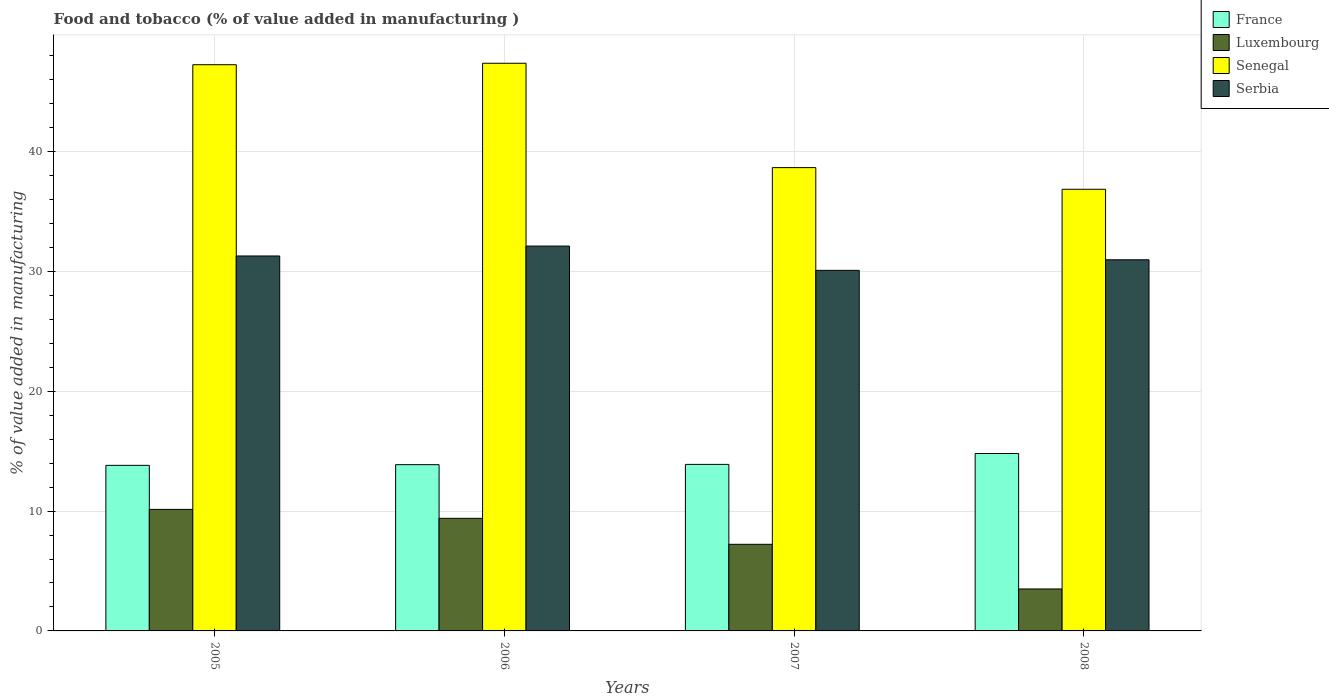How many groups of bars are there?
Make the answer very short. 4. Are the number of bars on each tick of the X-axis equal?
Your answer should be very brief. Yes. How many bars are there on the 1st tick from the left?
Your answer should be very brief. 4. How many bars are there on the 1st tick from the right?
Keep it short and to the point. 4. What is the label of the 4th group of bars from the left?
Your response must be concise. 2008. What is the value added in manufacturing food and tobacco in Serbia in 2006?
Give a very brief answer. 32.12. Across all years, what is the maximum value added in manufacturing food and tobacco in Serbia?
Give a very brief answer. 32.12. Across all years, what is the minimum value added in manufacturing food and tobacco in Senegal?
Your answer should be compact. 36.86. In which year was the value added in manufacturing food and tobacco in Luxembourg maximum?
Offer a terse response. 2005. In which year was the value added in manufacturing food and tobacco in Luxembourg minimum?
Ensure brevity in your answer.  2008. What is the total value added in manufacturing food and tobacco in Luxembourg in the graph?
Your answer should be very brief. 30.27. What is the difference between the value added in manufacturing food and tobacco in Luxembourg in 2006 and that in 2008?
Make the answer very short. 5.9. What is the difference between the value added in manufacturing food and tobacco in France in 2005 and the value added in manufacturing food and tobacco in Serbia in 2006?
Your response must be concise. -18.3. What is the average value added in manufacturing food and tobacco in France per year?
Provide a short and direct response. 14.1. In the year 2008, what is the difference between the value added in manufacturing food and tobacco in Serbia and value added in manufacturing food and tobacco in France?
Give a very brief answer. 16.17. What is the ratio of the value added in manufacturing food and tobacco in France in 2007 to that in 2008?
Ensure brevity in your answer.  0.94. Is the value added in manufacturing food and tobacco in Luxembourg in 2007 less than that in 2008?
Ensure brevity in your answer.  No. What is the difference between the highest and the second highest value added in manufacturing food and tobacco in Luxembourg?
Your response must be concise. 0.75. What is the difference between the highest and the lowest value added in manufacturing food and tobacco in Serbia?
Provide a succinct answer. 2.03. What does the 3rd bar from the left in 2006 represents?
Ensure brevity in your answer.  Senegal. What does the 1st bar from the right in 2008 represents?
Give a very brief answer. Serbia. Is it the case that in every year, the sum of the value added in manufacturing food and tobacco in Serbia and value added in manufacturing food and tobacco in France is greater than the value added in manufacturing food and tobacco in Luxembourg?
Your answer should be compact. Yes. How many bars are there?
Keep it short and to the point. 16. How many years are there in the graph?
Keep it short and to the point. 4. What is the difference between two consecutive major ticks on the Y-axis?
Your answer should be very brief. 10. Are the values on the major ticks of Y-axis written in scientific E-notation?
Your answer should be compact. No. Does the graph contain any zero values?
Give a very brief answer. No. Does the graph contain grids?
Keep it short and to the point. Yes. How many legend labels are there?
Your answer should be very brief. 4. How are the legend labels stacked?
Provide a succinct answer. Vertical. What is the title of the graph?
Keep it short and to the point. Food and tobacco (% of value added in manufacturing ). What is the label or title of the X-axis?
Provide a short and direct response. Years. What is the label or title of the Y-axis?
Give a very brief answer. % of value added in manufacturing. What is the % of value added in manufacturing in France in 2005?
Offer a very short reply. 13.82. What is the % of value added in manufacturing in Luxembourg in 2005?
Offer a terse response. 10.14. What is the % of value added in manufacturing in Senegal in 2005?
Make the answer very short. 47.25. What is the % of value added in manufacturing of Serbia in 2005?
Ensure brevity in your answer.  31.29. What is the % of value added in manufacturing of France in 2006?
Keep it short and to the point. 13.88. What is the % of value added in manufacturing of Luxembourg in 2006?
Provide a short and direct response. 9.4. What is the % of value added in manufacturing in Senegal in 2006?
Your answer should be very brief. 47.38. What is the % of value added in manufacturing of Serbia in 2006?
Give a very brief answer. 32.12. What is the % of value added in manufacturing in France in 2007?
Keep it short and to the point. 13.9. What is the % of value added in manufacturing in Luxembourg in 2007?
Your answer should be compact. 7.23. What is the % of value added in manufacturing in Senegal in 2007?
Offer a terse response. 38.67. What is the % of value added in manufacturing in Serbia in 2007?
Ensure brevity in your answer.  30.09. What is the % of value added in manufacturing of France in 2008?
Keep it short and to the point. 14.81. What is the % of value added in manufacturing of Luxembourg in 2008?
Keep it short and to the point. 3.5. What is the % of value added in manufacturing of Senegal in 2008?
Offer a terse response. 36.86. What is the % of value added in manufacturing in Serbia in 2008?
Your response must be concise. 30.97. Across all years, what is the maximum % of value added in manufacturing in France?
Your response must be concise. 14.81. Across all years, what is the maximum % of value added in manufacturing in Luxembourg?
Offer a terse response. 10.14. Across all years, what is the maximum % of value added in manufacturing of Senegal?
Provide a succinct answer. 47.38. Across all years, what is the maximum % of value added in manufacturing in Serbia?
Keep it short and to the point. 32.12. Across all years, what is the minimum % of value added in manufacturing of France?
Make the answer very short. 13.82. Across all years, what is the minimum % of value added in manufacturing in Luxembourg?
Give a very brief answer. 3.5. Across all years, what is the minimum % of value added in manufacturing of Senegal?
Your answer should be compact. 36.86. Across all years, what is the minimum % of value added in manufacturing of Serbia?
Keep it short and to the point. 30.09. What is the total % of value added in manufacturing in France in the graph?
Your response must be concise. 56.4. What is the total % of value added in manufacturing of Luxembourg in the graph?
Provide a succinct answer. 30.27. What is the total % of value added in manufacturing in Senegal in the graph?
Offer a very short reply. 170.16. What is the total % of value added in manufacturing of Serbia in the graph?
Your answer should be very brief. 124.48. What is the difference between the % of value added in manufacturing in France in 2005 and that in 2006?
Provide a succinct answer. -0.06. What is the difference between the % of value added in manufacturing of Luxembourg in 2005 and that in 2006?
Provide a short and direct response. 0.75. What is the difference between the % of value added in manufacturing of Senegal in 2005 and that in 2006?
Ensure brevity in your answer.  -0.12. What is the difference between the % of value added in manufacturing of Serbia in 2005 and that in 2006?
Your answer should be very brief. -0.83. What is the difference between the % of value added in manufacturing in France in 2005 and that in 2007?
Keep it short and to the point. -0.08. What is the difference between the % of value added in manufacturing in Luxembourg in 2005 and that in 2007?
Provide a succinct answer. 2.91. What is the difference between the % of value added in manufacturing of Senegal in 2005 and that in 2007?
Provide a succinct answer. 8.59. What is the difference between the % of value added in manufacturing in Serbia in 2005 and that in 2007?
Keep it short and to the point. 1.2. What is the difference between the % of value added in manufacturing of France in 2005 and that in 2008?
Your answer should be very brief. -0.99. What is the difference between the % of value added in manufacturing of Luxembourg in 2005 and that in 2008?
Provide a succinct answer. 6.64. What is the difference between the % of value added in manufacturing in Senegal in 2005 and that in 2008?
Provide a succinct answer. 10.4. What is the difference between the % of value added in manufacturing of Serbia in 2005 and that in 2008?
Offer a very short reply. 0.32. What is the difference between the % of value added in manufacturing in France in 2006 and that in 2007?
Your answer should be very brief. -0.02. What is the difference between the % of value added in manufacturing of Luxembourg in 2006 and that in 2007?
Offer a terse response. 2.17. What is the difference between the % of value added in manufacturing in Senegal in 2006 and that in 2007?
Keep it short and to the point. 8.71. What is the difference between the % of value added in manufacturing in Serbia in 2006 and that in 2007?
Provide a succinct answer. 2.03. What is the difference between the % of value added in manufacturing of France in 2006 and that in 2008?
Offer a terse response. -0.93. What is the difference between the % of value added in manufacturing of Luxembourg in 2006 and that in 2008?
Your response must be concise. 5.9. What is the difference between the % of value added in manufacturing of Senegal in 2006 and that in 2008?
Offer a very short reply. 10.52. What is the difference between the % of value added in manufacturing of Serbia in 2006 and that in 2008?
Your answer should be compact. 1.15. What is the difference between the % of value added in manufacturing of France in 2007 and that in 2008?
Keep it short and to the point. -0.91. What is the difference between the % of value added in manufacturing of Luxembourg in 2007 and that in 2008?
Make the answer very short. 3.73. What is the difference between the % of value added in manufacturing in Senegal in 2007 and that in 2008?
Your answer should be very brief. 1.81. What is the difference between the % of value added in manufacturing in Serbia in 2007 and that in 2008?
Make the answer very short. -0.88. What is the difference between the % of value added in manufacturing in France in 2005 and the % of value added in manufacturing in Luxembourg in 2006?
Offer a very short reply. 4.42. What is the difference between the % of value added in manufacturing in France in 2005 and the % of value added in manufacturing in Senegal in 2006?
Ensure brevity in your answer.  -33.56. What is the difference between the % of value added in manufacturing of France in 2005 and the % of value added in manufacturing of Serbia in 2006?
Your answer should be compact. -18.3. What is the difference between the % of value added in manufacturing of Luxembourg in 2005 and the % of value added in manufacturing of Senegal in 2006?
Ensure brevity in your answer.  -37.23. What is the difference between the % of value added in manufacturing in Luxembourg in 2005 and the % of value added in manufacturing in Serbia in 2006?
Make the answer very short. -21.98. What is the difference between the % of value added in manufacturing in Senegal in 2005 and the % of value added in manufacturing in Serbia in 2006?
Ensure brevity in your answer.  15.13. What is the difference between the % of value added in manufacturing in France in 2005 and the % of value added in manufacturing in Luxembourg in 2007?
Your response must be concise. 6.59. What is the difference between the % of value added in manufacturing in France in 2005 and the % of value added in manufacturing in Senegal in 2007?
Offer a very short reply. -24.85. What is the difference between the % of value added in manufacturing of France in 2005 and the % of value added in manufacturing of Serbia in 2007?
Your response must be concise. -16.27. What is the difference between the % of value added in manufacturing of Luxembourg in 2005 and the % of value added in manufacturing of Senegal in 2007?
Ensure brevity in your answer.  -28.52. What is the difference between the % of value added in manufacturing of Luxembourg in 2005 and the % of value added in manufacturing of Serbia in 2007?
Ensure brevity in your answer.  -19.95. What is the difference between the % of value added in manufacturing in Senegal in 2005 and the % of value added in manufacturing in Serbia in 2007?
Offer a very short reply. 17.16. What is the difference between the % of value added in manufacturing in France in 2005 and the % of value added in manufacturing in Luxembourg in 2008?
Your answer should be compact. 10.32. What is the difference between the % of value added in manufacturing of France in 2005 and the % of value added in manufacturing of Senegal in 2008?
Offer a terse response. -23.04. What is the difference between the % of value added in manufacturing of France in 2005 and the % of value added in manufacturing of Serbia in 2008?
Your answer should be compact. -17.16. What is the difference between the % of value added in manufacturing in Luxembourg in 2005 and the % of value added in manufacturing in Senegal in 2008?
Keep it short and to the point. -26.72. What is the difference between the % of value added in manufacturing of Luxembourg in 2005 and the % of value added in manufacturing of Serbia in 2008?
Your response must be concise. -20.83. What is the difference between the % of value added in manufacturing of Senegal in 2005 and the % of value added in manufacturing of Serbia in 2008?
Provide a succinct answer. 16.28. What is the difference between the % of value added in manufacturing of France in 2006 and the % of value added in manufacturing of Luxembourg in 2007?
Give a very brief answer. 6.65. What is the difference between the % of value added in manufacturing of France in 2006 and the % of value added in manufacturing of Senegal in 2007?
Ensure brevity in your answer.  -24.79. What is the difference between the % of value added in manufacturing of France in 2006 and the % of value added in manufacturing of Serbia in 2007?
Ensure brevity in your answer.  -16.22. What is the difference between the % of value added in manufacturing of Luxembourg in 2006 and the % of value added in manufacturing of Senegal in 2007?
Give a very brief answer. -29.27. What is the difference between the % of value added in manufacturing of Luxembourg in 2006 and the % of value added in manufacturing of Serbia in 2007?
Make the answer very short. -20.69. What is the difference between the % of value added in manufacturing of Senegal in 2006 and the % of value added in manufacturing of Serbia in 2007?
Give a very brief answer. 17.28. What is the difference between the % of value added in manufacturing of France in 2006 and the % of value added in manufacturing of Luxembourg in 2008?
Offer a terse response. 10.37. What is the difference between the % of value added in manufacturing in France in 2006 and the % of value added in manufacturing in Senegal in 2008?
Offer a terse response. -22.98. What is the difference between the % of value added in manufacturing of France in 2006 and the % of value added in manufacturing of Serbia in 2008?
Provide a succinct answer. -17.1. What is the difference between the % of value added in manufacturing in Luxembourg in 2006 and the % of value added in manufacturing in Senegal in 2008?
Offer a terse response. -27.46. What is the difference between the % of value added in manufacturing in Luxembourg in 2006 and the % of value added in manufacturing in Serbia in 2008?
Your answer should be very brief. -21.58. What is the difference between the % of value added in manufacturing in Senegal in 2006 and the % of value added in manufacturing in Serbia in 2008?
Your answer should be very brief. 16.4. What is the difference between the % of value added in manufacturing in France in 2007 and the % of value added in manufacturing in Luxembourg in 2008?
Make the answer very short. 10.4. What is the difference between the % of value added in manufacturing of France in 2007 and the % of value added in manufacturing of Senegal in 2008?
Provide a succinct answer. -22.96. What is the difference between the % of value added in manufacturing of France in 2007 and the % of value added in manufacturing of Serbia in 2008?
Offer a terse response. -17.08. What is the difference between the % of value added in manufacturing in Luxembourg in 2007 and the % of value added in manufacturing in Senegal in 2008?
Your response must be concise. -29.63. What is the difference between the % of value added in manufacturing in Luxembourg in 2007 and the % of value added in manufacturing in Serbia in 2008?
Provide a succinct answer. -23.75. What is the difference between the % of value added in manufacturing in Senegal in 2007 and the % of value added in manufacturing in Serbia in 2008?
Offer a terse response. 7.69. What is the average % of value added in manufacturing of France per year?
Provide a short and direct response. 14.1. What is the average % of value added in manufacturing in Luxembourg per year?
Keep it short and to the point. 7.57. What is the average % of value added in manufacturing in Senegal per year?
Ensure brevity in your answer.  42.54. What is the average % of value added in manufacturing in Serbia per year?
Give a very brief answer. 31.12. In the year 2005, what is the difference between the % of value added in manufacturing in France and % of value added in manufacturing in Luxembourg?
Offer a very short reply. 3.68. In the year 2005, what is the difference between the % of value added in manufacturing in France and % of value added in manufacturing in Senegal?
Make the answer very short. -33.44. In the year 2005, what is the difference between the % of value added in manufacturing in France and % of value added in manufacturing in Serbia?
Your answer should be compact. -17.47. In the year 2005, what is the difference between the % of value added in manufacturing in Luxembourg and % of value added in manufacturing in Senegal?
Your answer should be very brief. -37.11. In the year 2005, what is the difference between the % of value added in manufacturing of Luxembourg and % of value added in manufacturing of Serbia?
Ensure brevity in your answer.  -21.15. In the year 2005, what is the difference between the % of value added in manufacturing of Senegal and % of value added in manufacturing of Serbia?
Your response must be concise. 15.96. In the year 2006, what is the difference between the % of value added in manufacturing of France and % of value added in manufacturing of Luxembourg?
Offer a terse response. 4.48. In the year 2006, what is the difference between the % of value added in manufacturing of France and % of value added in manufacturing of Senegal?
Give a very brief answer. -33.5. In the year 2006, what is the difference between the % of value added in manufacturing of France and % of value added in manufacturing of Serbia?
Make the answer very short. -18.25. In the year 2006, what is the difference between the % of value added in manufacturing in Luxembourg and % of value added in manufacturing in Senegal?
Give a very brief answer. -37.98. In the year 2006, what is the difference between the % of value added in manufacturing in Luxembourg and % of value added in manufacturing in Serbia?
Your response must be concise. -22.72. In the year 2006, what is the difference between the % of value added in manufacturing of Senegal and % of value added in manufacturing of Serbia?
Ensure brevity in your answer.  15.26. In the year 2007, what is the difference between the % of value added in manufacturing of France and % of value added in manufacturing of Luxembourg?
Your response must be concise. 6.67. In the year 2007, what is the difference between the % of value added in manufacturing of France and % of value added in manufacturing of Senegal?
Offer a terse response. -24.77. In the year 2007, what is the difference between the % of value added in manufacturing of France and % of value added in manufacturing of Serbia?
Your answer should be very brief. -16.2. In the year 2007, what is the difference between the % of value added in manufacturing in Luxembourg and % of value added in manufacturing in Senegal?
Ensure brevity in your answer.  -31.44. In the year 2007, what is the difference between the % of value added in manufacturing of Luxembourg and % of value added in manufacturing of Serbia?
Offer a terse response. -22.86. In the year 2007, what is the difference between the % of value added in manufacturing of Senegal and % of value added in manufacturing of Serbia?
Your response must be concise. 8.57. In the year 2008, what is the difference between the % of value added in manufacturing of France and % of value added in manufacturing of Luxembourg?
Provide a succinct answer. 11.31. In the year 2008, what is the difference between the % of value added in manufacturing in France and % of value added in manufacturing in Senegal?
Your response must be concise. -22.05. In the year 2008, what is the difference between the % of value added in manufacturing of France and % of value added in manufacturing of Serbia?
Offer a terse response. -16.17. In the year 2008, what is the difference between the % of value added in manufacturing of Luxembourg and % of value added in manufacturing of Senegal?
Provide a succinct answer. -33.36. In the year 2008, what is the difference between the % of value added in manufacturing in Luxembourg and % of value added in manufacturing in Serbia?
Keep it short and to the point. -27.47. In the year 2008, what is the difference between the % of value added in manufacturing in Senegal and % of value added in manufacturing in Serbia?
Offer a terse response. 5.88. What is the ratio of the % of value added in manufacturing in Luxembourg in 2005 to that in 2006?
Keep it short and to the point. 1.08. What is the ratio of the % of value added in manufacturing of Serbia in 2005 to that in 2006?
Give a very brief answer. 0.97. What is the ratio of the % of value added in manufacturing of France in 2005 to that in 2007?
Provide a succinct answer. 0.99. What is the ratio of the % of value added in manufacturing of Luxembourg in 2005 to that in 2007?
Your answer should be very brief. 1.4. What is the ratio of the % of value added in manufacturing of Senegal in 2005 to that in 2007?
Ensure brevity in your answer.  1.22. What is the ratio of the % of value added in manufacturing in Serbia in 2005 to that in 2007?
Your answer should be very brief. 1.04. What is the ratio of the % of value added in manufacturing of France in 2005 to that in 2008?
Offer a terse response. 0.93. What is the ratio of the % of value added in manufacturing in Luxembourg in 2005 to that in 2008?
Give a very brief answer. 2.9. What is the ratio of the % of value added in manufacturing in Senegal in 2005 to that in 2008?
Offer a terse response. 1.28. What is the ratio of the % of value added in manufacturing of Serbia in 2005 to that in 2008?
Your answer should be very brief. 1.01. What is the ratio of the % of value added in manufacturing in Senegal in 2006 to that in 2007?
Keep it short and to the point. 1.23. What is the ratio of the % of value added in manufacturing of Serbia in 2006 to that in 2007?
Ensure brevity in your answer.  1.07. What is the ratio of the % of value added in manufacturing of France in 2006 to that in 2008?
Give a very brief answer. 0.94. What is the ratio of the % of value added in manufacturing of Luxembourg in 2006 to that in 2008?
Make the answer very short. 2.68. What is the ratio of the % of value added in manufacturing of Senegal in 2006 to that in 2008?
Your response must be concise. 1.29. What is the ratio of the % of value added in manufacturing of Serbia in 2006 to that in 2008?
Ensure brevity in your answer.  1.04. What is the ratio of the % of value added in manufacturing of France in 2007 to that in 2008?
Offer a very short reply. 0.94. What is the ratio of the % of value added in manufacturing of Luxembourg in 2007 to that in 2008?
Your answer should be very brief. 2.06. What is the ratio of the % of value added in manufacturing of Senegal in 2007 to that in 2008?
Offer a very short reply. 1.05. What is the ratio of the % of value added in manufacturing in Serbia in 2007 to that in 2008?
Your answer should be compact. 0.97. What is the difference between the highest and the second highest % of value added in manufacturing of France?
Give a very brief answer. 0.91. What is the difference between the highest and the second highest % of value added in manufacturing of Luxembourg?
Your answer should be compact. 0.75. What is the difference between the highest and the second highest % of value added in manufacturing in Senegal?
Give a very brief answer. 0.12. What is the difference between the highest and the second highest % of value added in manufacturing in Serbia?
Your response must be concise. 0.83. What is the difference between the highest and the lowest % of value added in manufacturing in Luxembourg?
Your response must be concise. 6.64. What is the difference between the highest and the lowest % of value added in manufacturing in Senegal?
Your response must be concise. 10.52. What is the difference between the highest and the lowest % of value added in manufacturing in Serbia?
Keep it short and to the point. 2.03. 